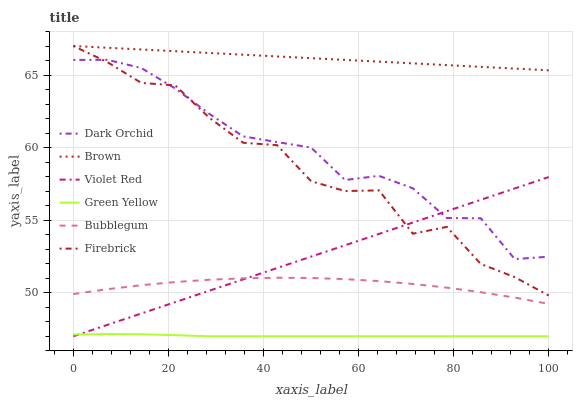Does Green Yellow have the minimum area under the curve?
Answer yes or no. Yes. Does Brown have the maximum area under the curve?
Answer yes or no. Yes. Does Violet Red have the minimum area under the curve?
Answer yes or no. No. Does Violet Red have the maximum area under the curve?
Answer yes or no. No. Is Violet Red the smoothest?
Answer yes or no. Yes. Is Firebrick the roughest?
Answer yes or no. Yes. Is Firebrick the smoothest?
Answer yes or no. No. Is Violet Red the roughest?
Answer yes or no. No. Does Violet Red have the lowest value?
Answer yes or no. Yes. Does Firebrick have the lowest value?
Answer yes or no. No. Does Firebrick have the highest value?
Answer yes or no. Yes. Does Violet Red have the highest value?
Answer yes or no. No. Is Violet Red less than Brown?
Answer yes or no. Yes. Is Dark Orchid greater than Bubblegum?
Answer yes or no. Yes. Does Dark Orchid intersect Firebrick?
Answer yes or no. Yes. Is Dark Orchid less than Firebrick?
Answer yes or no. No. Is Dark Orchid greater than Firebrick?
Answer yes or no. No. Does Violet Red intersect Brown?
Answer yes or no. No. 